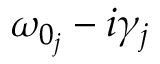Convert formula to latex. <formula><loc_0><loc_0><loc_500><loc_500>\omega _ { 0 _ { j } } - i \gamma _ { j }</formula> 